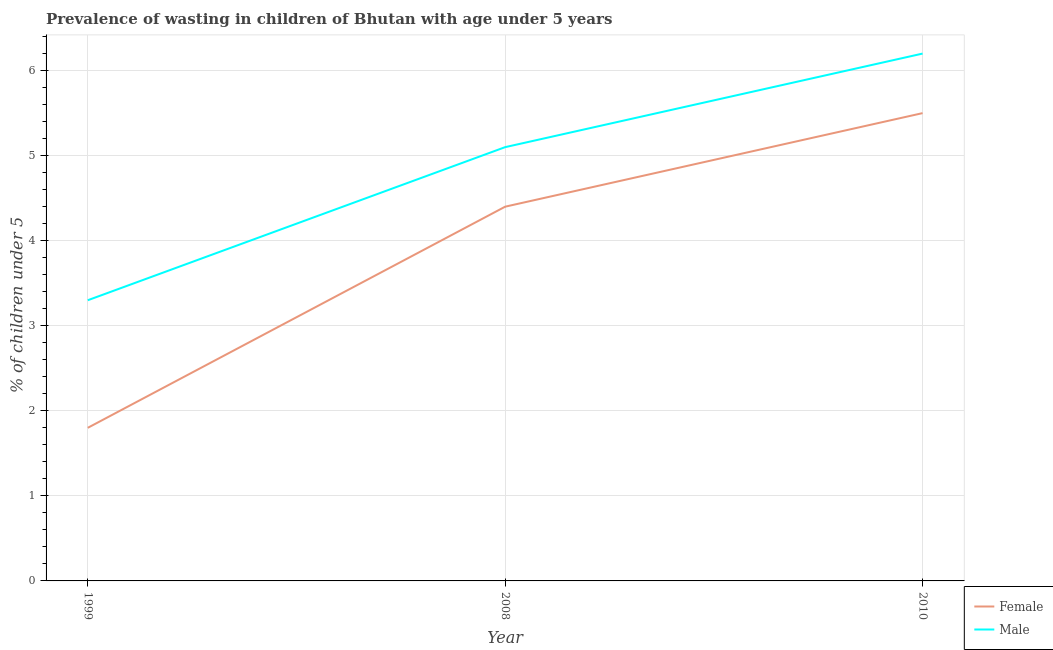What is the percentage of undernourished female children in 2008?
Your answer should be compact. 4.4. Across all years, what is the maximum percentage of undernourished female children?
Provide a short and direct response. 5.5. Across all years, what is the minimum percentage of undernourished female children?
Provide a short and direct response. 1.8. In which year was the percentage of undernourished female children maximum?
Your answer should be compact. 2010. In which year was the percentage of undernourished female children minimum?
Provide a succinct answer. 1999. What is the total percentage of undernourished male children in the graph?
Ensure brevity in your answer.  14.6. What is the difference between the percentage of undernourished female children in 2008 and that in 2010?
Keep it short and to the point. -1.1. What is the difference between the percentage of undernourished male children in 2008 and the percentage of undernourished female children in 2010?
Offer a very short reply. -0.4. What is the average percentage of undernourished female children per year?
Make the answer very short. 3.9. In the year 2008, what is the difference between the percentage of undernourished male children and percentage of undernourished female children?
Your answer should be very brief. 0.7. What is the ratio of the percentage of undernourished female children in 2008 to that in 2010?
Provide a short and direct response. 0.8. Is the percentage of undernourished male children in 2008 less than that in 2010?
Make the answer very short. Yes. What is the difference between the highest and the second highest percentage of undernourished male children?
Provide a succinct answer. 1.1. What is the difference between the highest and the lowest percentage of undernourished male children?
Your response must be concise. 2.9. In how many years, is the percentage of undernourished female children greater than the average percentage of undernourished female children taken over all years?
Keep it short and to the point. 2. How many lines are there?
Your answer should be compact. 2. What is the difference between two consecutive major ticks on the Y-axis?
Make the answer very short. 1. Are the values on the major ticks of Y-axis written in scientific E-notation?
Your answer should be compact. No. Does the graph contain any zero values?
Provide a succinct answer. No. How many legend labels are there?
Make the answer very short. 2. What is the title of the graph?
Your answer should be compact. Prevalence of wasting in children of Bhutan with age under 5 years. What is the label or title of the X-axis?
Provide a succinct answer. Year. What is the label or title of the Y-axis?
Keep it short and to the point.  % of children under 5. What is the  % of children under 5 of Female in 1999?
Your answer should be compact. 1.8. What is the  % of children under 5 in Male in 1999?
Give a very brief answer. 3.3. What is the  % of children under 5 in Female in 2008?
Make the answer very short. 4.4. What is the  % of children under 5 of Male in 2008?
Make the answer very short. 5.1. What is the  % of children under 5 in Female in 2010?
Offer a terse response. 5.5. What is the  % of children under 5 in Male in 2010?
Keep it short and to the point. 6.2. Across all years, what is the maximum  % of children under 5 in Female?
Your answer should be compact. 5.5. Across all years, what is the maximum  % of children under 5 in Male?
Your response must be concise. 6.2. Across all years, what is the minimum  % of children under 5 in Female?
Your answer should be very brief. 1.8. Across all years, what is the minimum  % of children under 5 of Male?
Your answer should be very brief. 3.3. What is the total  % of children under 5 in Female in the graph?
Offer a very short reply. 11.7. What is the difference between the  % of children under 5 in Female in 1999 and that in 2008?
Provide a short and direct response. -2.6. What is the difference between the  % of children under 5 of Male in 1999 and that in 2008?
Ensure brevity in your answer.  -1.8. What is the difference between the  % of children under 5 of Female in 2008 and that in 2010?
Give a very brief answer. -1.1. What is the difference between the  % of children under 5 in Female in 1999 and the  % of children under 5 in Male in 2010?
Make the answer very short. -4.4. What is the average  % of children under 5 of Female per year?
Keep it short and to the point. 3.9. What is the average  % of children under 5 in Male per year?
Keep it short and to the point. 4.87. In the year 2010, what is the difference between the  % of children under 5 of Female and  % of children under 5 of Male?
Keep it short and to the point. -0.7. What is the ratio of the  % of children under 5 of Female in 1999 to that in 2008?
Give a very brief answer. 0.41. What is the ratio of the  % of children under 5 in Male in 1999 to that in 2008?
Offer a terse response. 0.65. What is the ratio of the  % of children under 5 in Female in 1999 to that in 2010?
Ensure brevity in your answer.  0.33. What is the ratio of the  % of children under 5 in Male in 1999 to that in 2010?
Make the answer very short. 0.53. What is the ratio of the  % of children under 5 of Female in 2008 to that in 2010?
Your response must be concise. 0.8. What is the ratio of the  % of children under 5 in Male in 2008 to that in 2010?
Offer a terse response. 0.82. What is the difference between the highest and the second highest  % of children under 5 in Female?
Offer a very short reply. 1.1. What is the difference between the highest and the lowest  % of children under 5 of Female?
Your answer should be very brief. 3.7. 